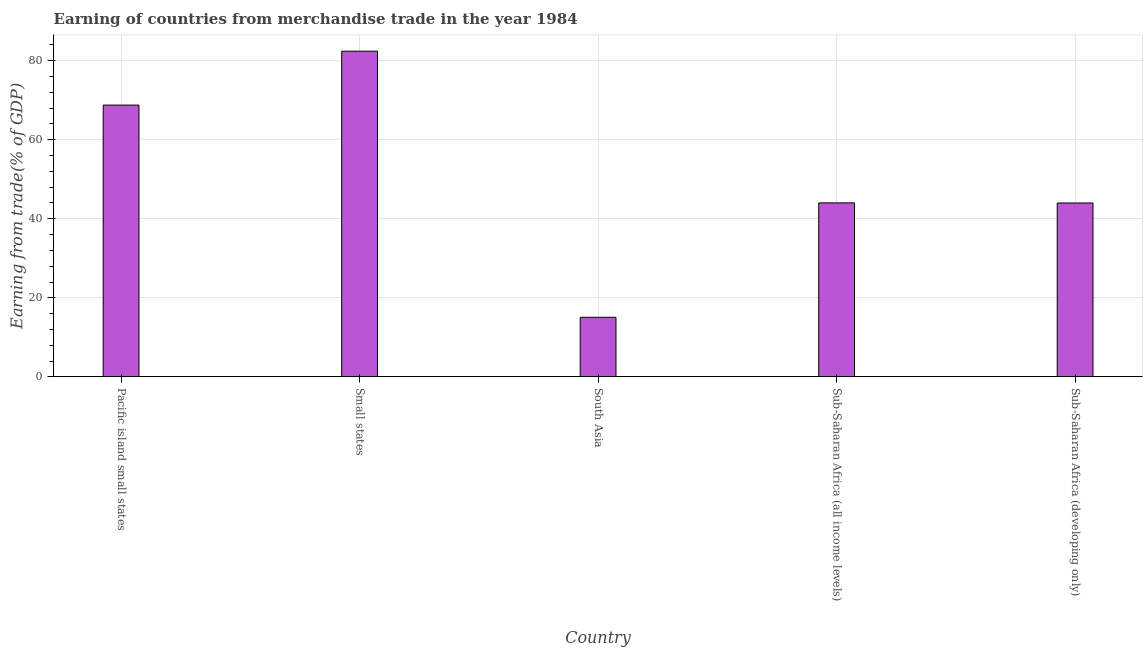Does the graph contain any zero values?
Make the answer very short. No. What is the title of the graph?
Keep it short and to the point. Earning of countries from merchandise trade in the year 1984. What is the label or title of the X-axis?
Make the answer very short. Country. What is the label or title of the Y-axis?
Make the answer very short. Earning from trade(% of GDP). What is the earning from merchandise trade in Small states?
Your answer should be very brief. 82.4. Across all countries, what is the maximum earning from merchandise trade?
Give a very brief answer. 82.4. Across all countries, what is the minimum earning from merchandise trade?
Your answer should be very brief. 15.07. In which country was the earning from merchandise trade maximum?
Give a very brief answer. Small states. What is the sum of the earning from merchandise trade?
Ensure brevity in your answer.  254.24. What is the difference between the earning from merchandise trade in Pacific island small states and Sub-Saharan Africa (developing only)?
Keep it short and to the point. 24.77. What is the average earning from merchandise trade per country?
Ensure brevity in your answer.  50.85. What is the median earning from merchandise trade?
Your answer should be very brief. 44.02. In how many countries, is the earning from merchandise trade greater than 68 %?
Offer a terse response. 2. What is the ratio of the earning from merchandise trade in South Asia to that in Sub-Saharan Africa (developing only)?
Provide a short and direct response. 0.34. Is the earning from merchandise trade in Small states less than that in Sub-Saharan Africa (all income levels)?
Your answer should be compact. No. What is the difference between the highest and the second highest earning from merchandise trade?
Offer a terse response. 13.64. Is the sum of the earning from merchandise trade in Pacific island small states and Sub-Saharan Africa (all income levels) greater than the maximum earning from merchandise trade across all countries?
Offer a terse response. Yes. What is the difference between the highest and the lowest earning from merchandise trade?
Ensure brevity in your answer.  67.33. In how many countries, is the earning from merchandise trade greater than the average earning from merchandise trade taken over all countries?
Ensure brevity in your answer.  2. How many countries are there in the graph?
Offer a terse response. 5. What is the difference between two consecutive major ticks on the Y-axis?
Provide a short and direct response. 20. What is the Earning from trade(% of GDP) in Pacific island small states?
Your answer should be compact. 68.76. What is the Earning from trade(% of GDP) in Small states?
Offer a very short reply. 82.4. What is the Earning from trade(% of GDP) of South Asia?
Keep it short and to the point. 15.07. What is the Earning from trade(% of GDP) in Sub-Saharan Africa (all income levels)?
Provide a succinct answer. 44.02. What is the Earning from trade(% of GDP) in Sub-Saharan Africa (developing only)?
Offer a terse response. 43.99. What is the difference between the Earning from trade(% of GDP) in Pacific island small states and Small states?
Offer a very short reply. -13.64. What is the difference between the Earning from trade(% of GDP) in Pacific island small states and South Asia?
Offer a terse response. 53.69. What is the difference between the Earning from trade(% of GDP) in Pacific island small states and Sub-Saharan Africa (all income levels)?
Offer a very short reply. 24.75. What is the difference between the Earning from trade(% of GDP) in Pacific island small states and Sub-Saharan Africa (developing only)?
Give a very brief answer. 24.77. What is the difference between the Earning from trade(% of GDP) in Small states and South Asia?
Keep it short and to the point. 67.33. What is the difference between the Earning from trade(% of GDP) in Small states and Sub-Saharan Africa (all income levels)?
Your answer should be very brief. 38.39. What is the difference between the Earning from trade(% of GDP) in Small states and Sub-Saharan Africa (developing only)?
Your response must be concise. 38.41. What is the difference between the Earning from trade(% of GDP) in South Asia and Sub-Saharan Africa (all income levels)?
Provide a succinct answer. -28.94. What is the difference between the Earning from trade(% of GDP) in South Asia and Sub-Saharan Africa (developing only)?
Provide a succinct answer. -28.91. What is the difference between the Earning from trade(% of GDP) in Sub-Saharan Africa (all income levels) and Sub-Saharan Africa (developing only)?
Offer a terse response. 0.03. What is the ratio of the Earning from trade(% of GDP) in Pacific island small states to that in Small states?
Keep it short and to the point. 0.83. What is the ratio of the Earning from trade(% of GDP) in Pacific island small states to that in South Asia?
Your response must be concise. 4.56. What is the ratio of the Earning from trade(% of GDP) in Pacific island small states to that in Sub-Saharan Africa (all income levels)?
Provide a short and direct response. 1.56. What is the ratio of the Earning from trade(% of GDP) in Pacific island small states to that in Sub-Saharan Africa (developing only)?
Offer a terse response. 1.56. What is the ratio of the Earning from trade(% of GDP) in Small states to that in South Asia?
Offer a very short reply. 5.47. What is the ratio of the Earning from trade(% of GDP) in Small states to that in Sub-Saharan Africa (all income levels)?
Provide a short and direct response. 1.87. What is the ratio of the Earning from trade(% of GDP) in Small states to that in Sub-Saharan Africa (developing only)?
Provide a succinct answer. 1.87. What is the ratio of the Earning from trade(% of GDP) in South Asia to that in Sub-Saharan Africa (all income levels)?
Your answer should be very brief. 0.34. What is the ratio of the Earning from trade(% of GDP) in South Asia to that in Sub-Saharan Africa (developing only)?
Offer a very short reply. 0.34. What is the ratio of the Earning from trade(% of GDP) in Sub-Saharan Africa (all income levels) to that in Sub-Saharan Africa (developing only)?
Make the answer very short. 1. 